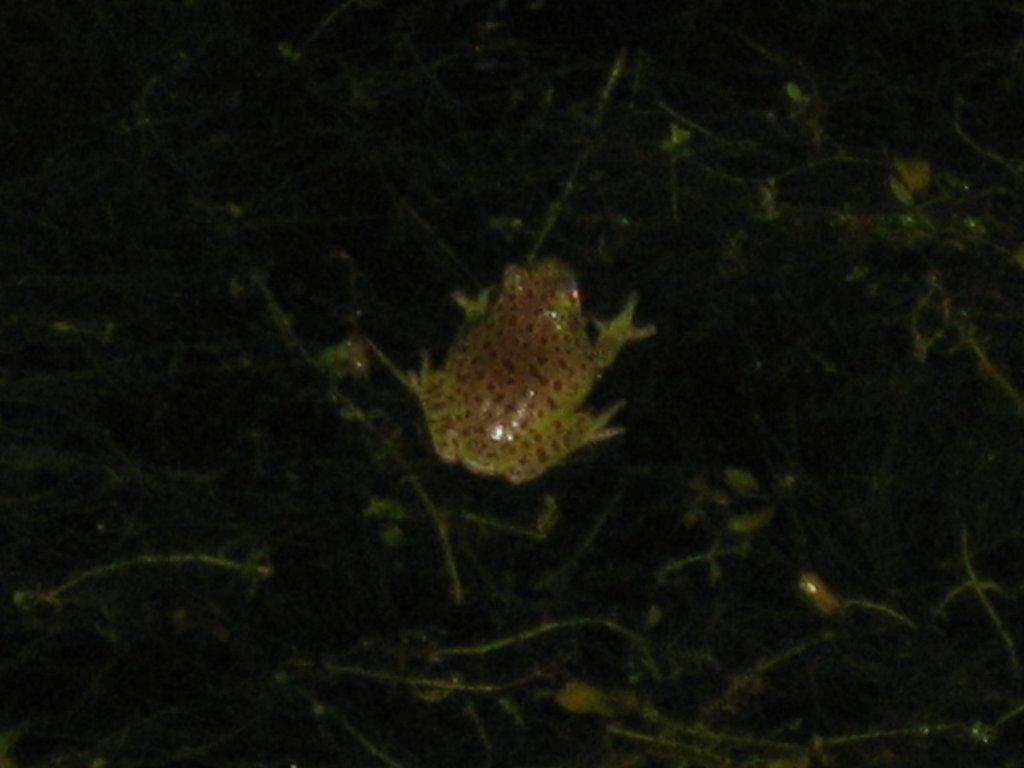Please provide a concise description of this image. In this image I can see the frog which is in brown and yellow color. It is on the black and green color surface. 